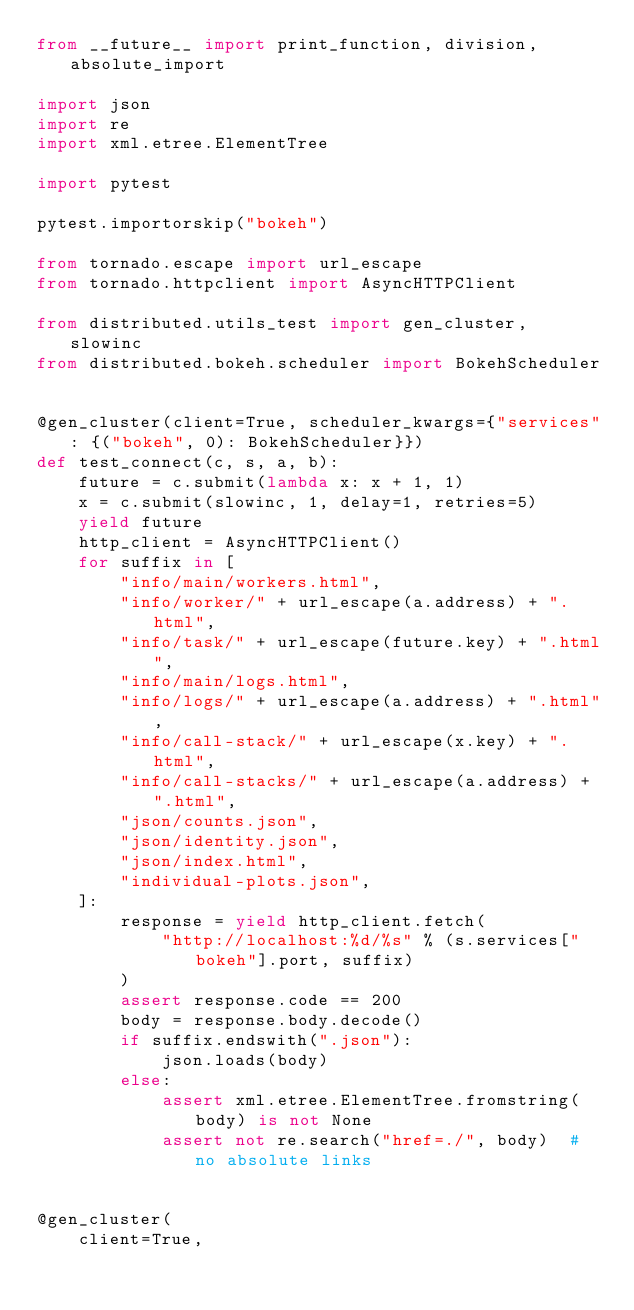Convert code to text. <code><loc_0><loc_0><loc_500><loc_500><_Python_>from __future__ import print_function, division, absolute_import

import json
import re
import xml.etree.ElementTree

import pytest

pytest.importorskip("bokeh")

from tornado.escape import url_escape
from tornado.httpclient import AsyncHTTPClient

from distributed.utils_test import gen_cluster, slowinc
from distributed.bokeh.scheduler import BokehScheduler


@gen_cluster(client=True, scheduler_kwargs={"services": {("bokeh", 0): BokehScheduler}})
def test_connect(c, s, a, b):
    future = c.submit(lambda x: x + 1, 1)
    x = c.submit(slowinc, 1, delay=1, retries=5)
    yield future
    http_client = AsyncHTTPClient()
    for suffix in [
        "info/main/workers.html",
        "info/worker/" + url_escape(a.address) + ".html",
        "info/task/" + url_escape(future.key) + ".html",
        "info/main/logs.html",
        "info/logs/" + url_escape(a.address) + ".html",
        "info/call-stack/" + url_escape(x.key) + ".html",
        "info/call-stacks/" + url_escape(a.address) + ".html",
        "json/counts.json",
        "json/identity.json",
        "json/index.html",
        "individual-plots.json",
    ]:
        response = yield http_client.fetch(
            "http://localhost:%d/%s" % (s.services["bokeh"].port, suffix)
        )
        assert response.code == 200
        body = response.body.decode()
        if suffix.endswith(".json"):
            json.loads(body)
        else:
            assert xml.etree.ElementTree.fromstring(body) is not None
            assert not re.search("href=./", body)  # no absolute links


@gen_cluster(
    client=True,</code> 